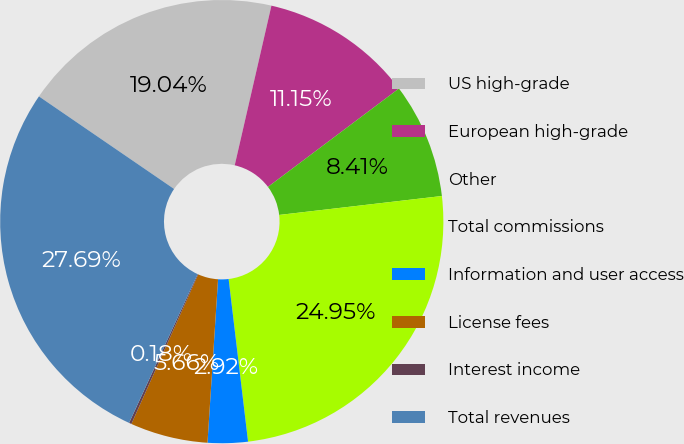Convert chart. <chart><loc_0><loc_0><loc_500><loc_500><pie_chart><fcel>US high-grade<fcel>European high-grade<fcel>Other<fcel>Total commissions<fcel>Information and user access<fcel>License fees<fcel>Interest income<fcel>Total revenues<nl><fcel>19.04%<fcel>11.15%<fcel>8.41%<fcel>24.95%<fcel>2.92%<fcel>5.66%<fcel>0.18%<fcel>27.69%<nl></chart> 